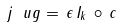<formula> <loc_0><loc_0><loc_500><loc_500>j _ { \ } u g = \, \epsilon \, I _ { k } \, \circ \, c</formula> 